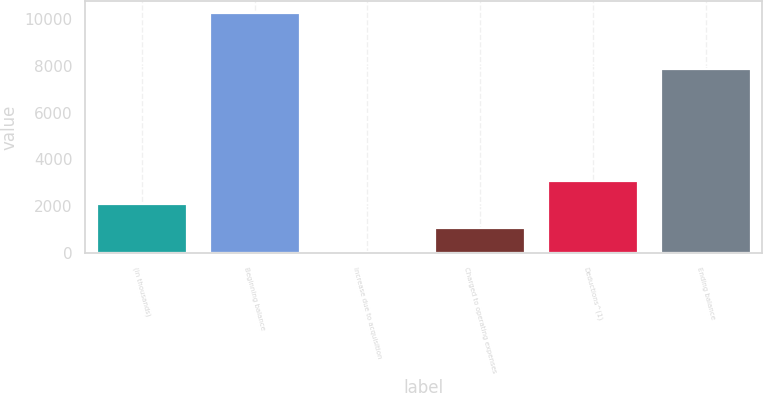<chart> <loc_0><loc_0><loc_500><loc_500><bar_chart><fcel>(in thousands)<fcel>Beginning balance<fcel>Increase due to acquisition<fcel>Charged to operating expenses<fcel>Deductions^(1)<fcel>Ending balance<nl><fcel>2086.4<fcel>10228<fcel>51<fcel>1068.7<fcel>3104.1<fcel>7867<nl></chart> 